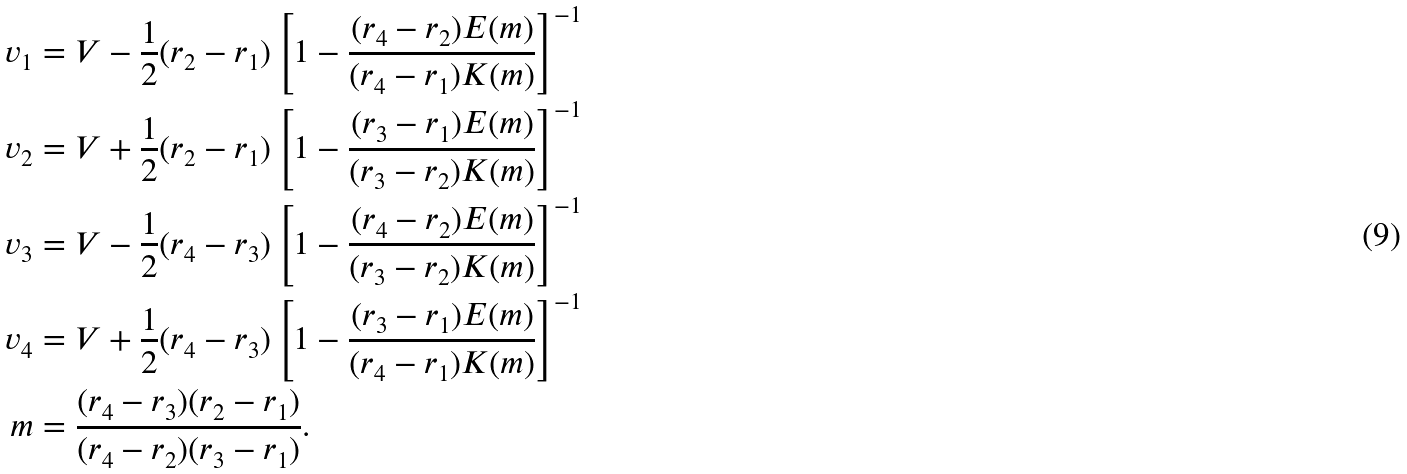Convert formula to latex. <formula><loc_0><loc_0><loc_500><loc_500>v _ { 1 } & = V - \frac { 1 } { 2 } ( r _ { 2 } - r _ { 1 } ) \left [ 1 - \frac { ( r _ { 4 } - r _ { 2 } ) E ( m ) } { ( r _ { 4 } - r _ { 1 } ) K ( m ) } \right ] ^ { - 1 } \\ v _ { 2 } & = V + \frac { 1 } { 2 } ( r _ { 2 } - r _ { 1 } ) \left [ 1 - \frac { ( r _ { 3 } - r _ { 1 } ) E ( m ) } { ( r _ { 3 } - r _ { 2 } ) K ( m ) } \right ] ^ { - 1 } \\ v _ { 3 } & = V - \frac { 1 } { 2 } ( r _ { 4 } - r _ { 3 } ) \left [ 1 - \frac { ( r _ { 4 } - r _ { 2 } ) E ( m ) } { ( r _ { 3 } - r _ { 2 } ) K ( m ) } \right ] ^ { - 1 } \\ v _ { 4 } & = V + \frac { 1 } { 2 } ( r _ { 4 } - r _ { 3 } ) \left [ 1 - \frac { ( r _ { 3 } - r _ { 1 } ) E ( m ) } { ( r _ { 4 } - r _ { 1 } ) K ( m ) } \right ] ^ { - 1 } \\ m & = \frac { ( r _ { 4 } - r _ { 3 } ) ( r _ { 2 } - r _ { 1 } ) } { ( r _ { 4 } - r _ { 2 } ) ( r _ { 3 } - r _ { 1 } ) } .</formula> 